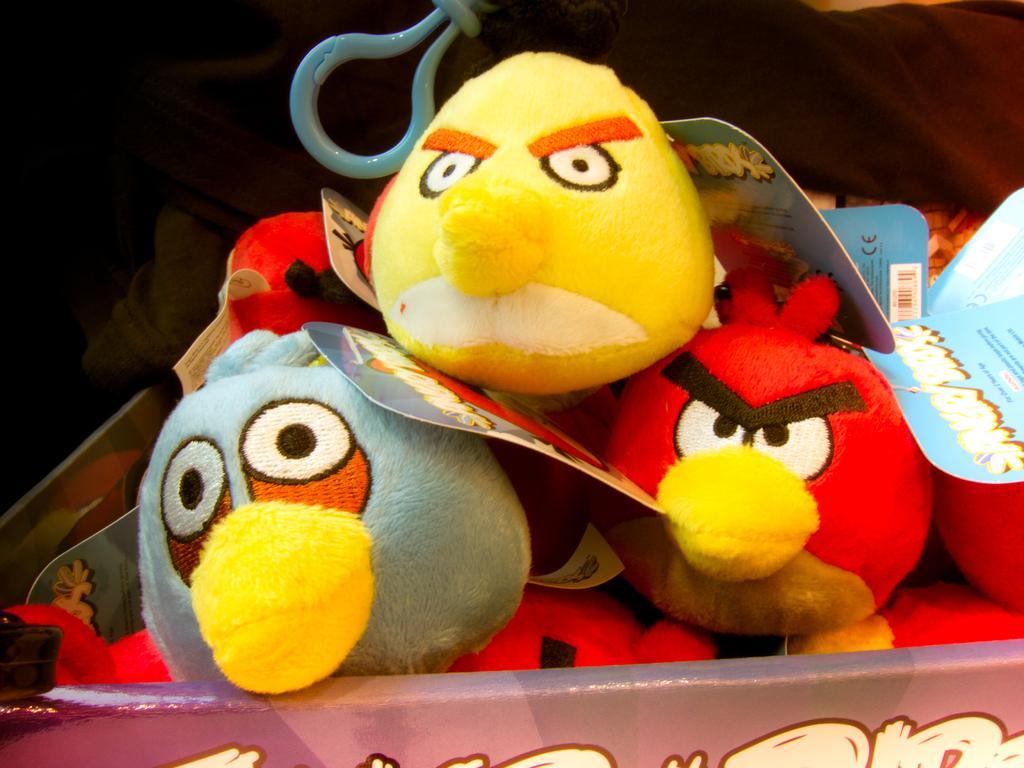Could you give a brief overview of what you see in this image? In the image we can see the toys and here we can see the tag, and the background is dark. 